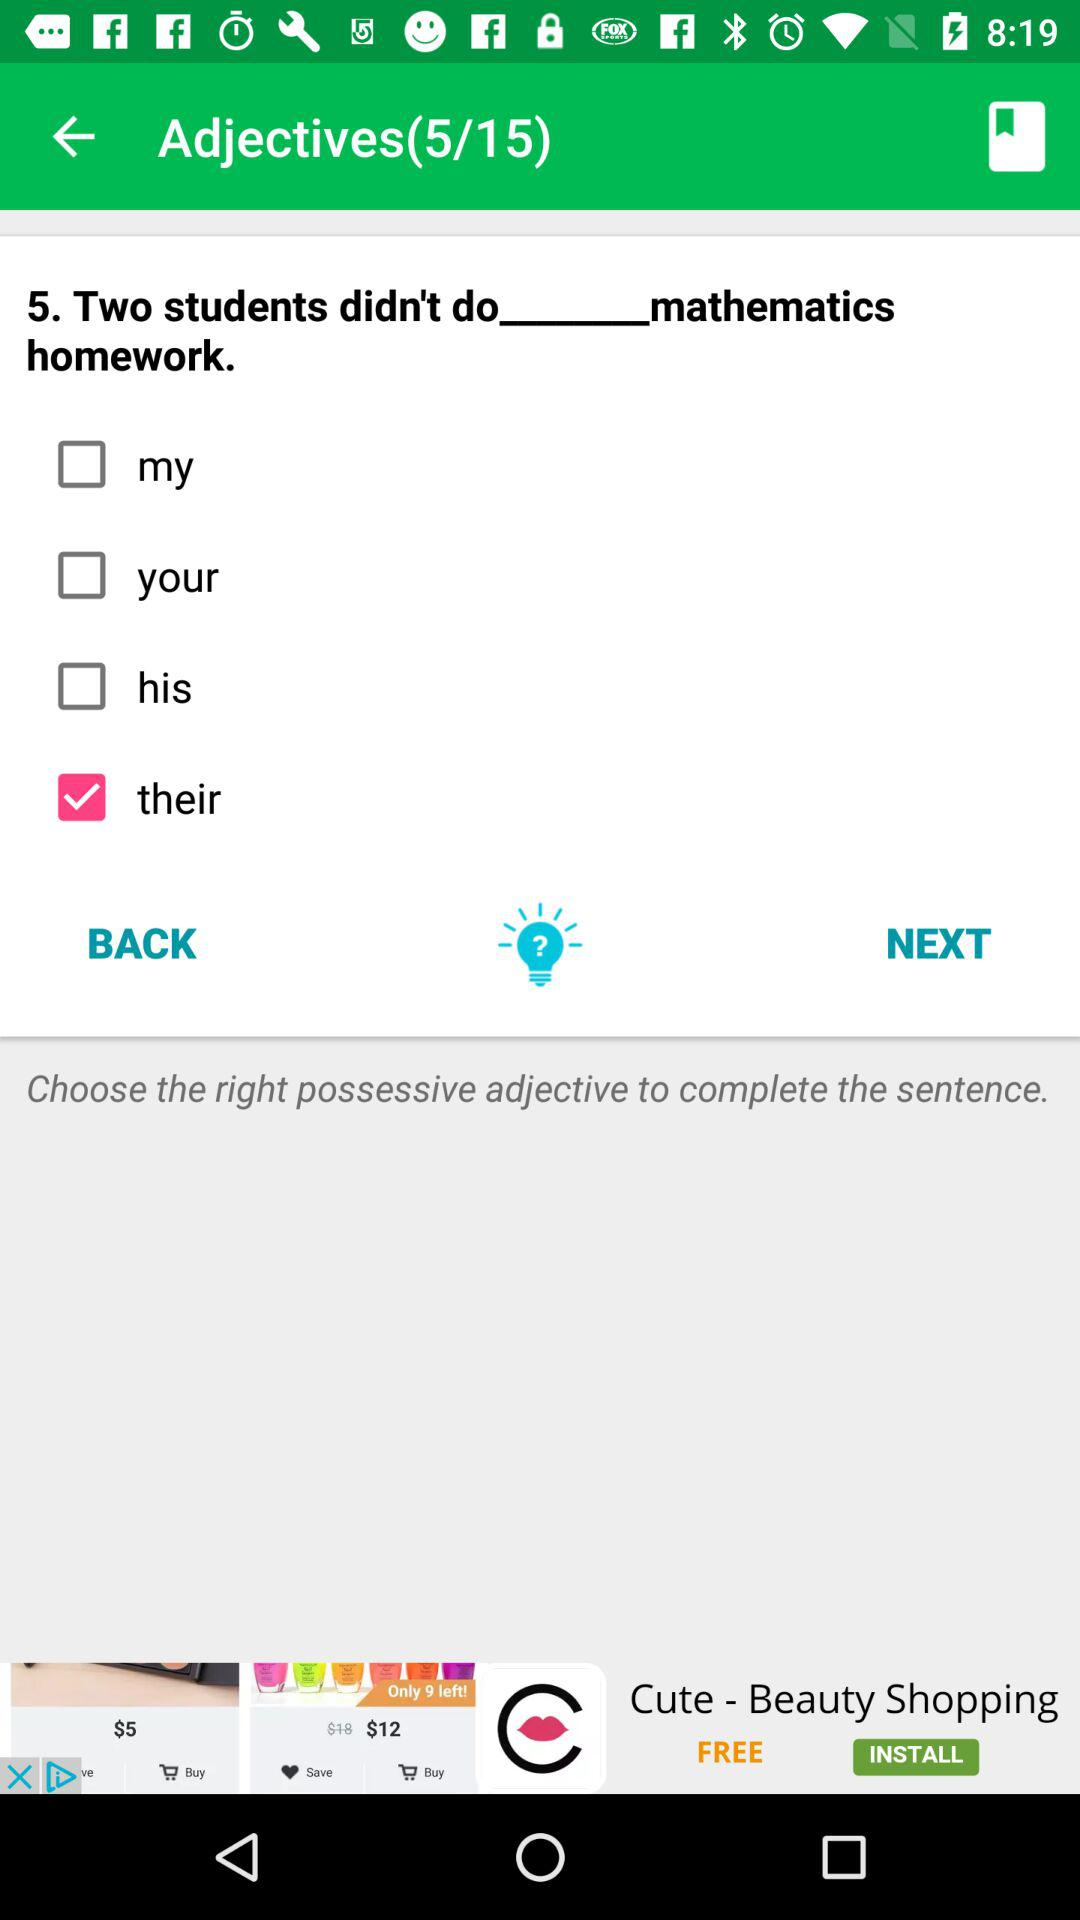How many possessive adjectives are there? In the English language exercise presented in the image, there is only one correct possessive adjective that completes the sentence properly: 'their.' Therefore, among the options given, only 'their' is the suitable possessive adjective to use. 